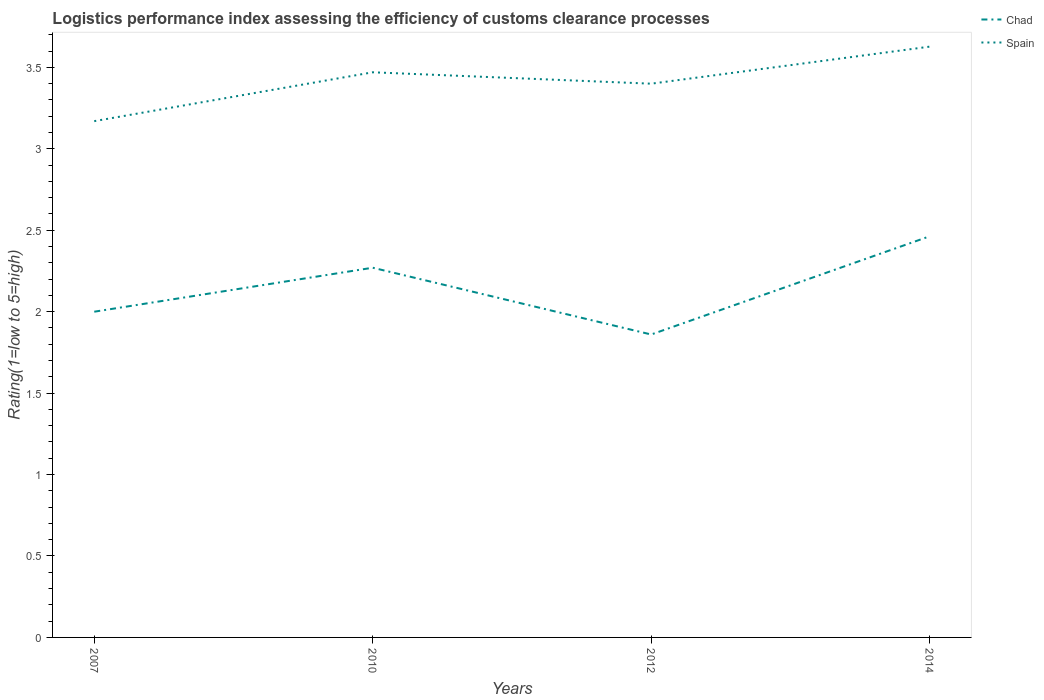How many different coloured lines are there?
Offer a terse response. 2. Does the line corresponding to Spain intersect with the line corresponding to Chad?
Offer a very short reply. No. Is the number of lines equal to the number of legend labels?
Your response must be concise. Yes. Across all years, what is the maximum Logistic performance index in Spain?
Make the answer very short. 3.17. What is the total Logistic performance index in Spain in the graph?
Keep it short and to the point. 0.07. What is the difference between the highest and the second highest Logistic performance index in Spain?
Make the answer very short. 0.46. How many lines are there?
Your response must be concise. 2. What is the difference between two consecutive major ticks on the Y-axis?
Provide a succinct answer. 0.5. Are the values on the major ticks of Y-axis written in scientific E-notation?
Keep it short and to the point. No. Does the graph contain any zero values?
Offer a very short reply. No. Where does the legend appear in the graph?
Provide a succinct answer. Top right. How many legend labels are there?
Offer a very short reply. 2. How are the legend labels stacked?
Offer a terse response. Vertical. What is the title of the graph?
Make the answer very short. Logistics performance index assessing the efficiency of customs clearance processes. What is the label or title of the X-axis?
Your answer should be very brief. Years. What is the label or title of the Y-axis?
Your answer should be very brief. Rating(1=low to 5=high). What is the Rating(1=low to 5=high) in Chad in 2007?
Provide a succinct answer. 2. What is the Rating(1=low to 5=high) in Spain in 2007?
Your answer should be very brief. 3.17. What is the Rating(1=low to 5=high) of Chad in 2010?
Your response must be concise. 2.27. What is the Rating(1=low to 5=high) in Spain in 2010?
Provide a short and direct response. 3.47. What is the Rating(1=low to 5=high) in Chad in 2012?
Provide a succinct answer. 1.86. What is the Rating(1=low to 5=high) in Chad in 2014?
Your response must be concise. 2.46. What is the Rating(1=low to 5=high) of Spain in 2014?
Your answer should be very brief. 3.63. Across all years, what is the maximum Rating(1=low to 5=high) of Chad?
Offer a terse response. 2.46. Across all years, what is the maximum Rating(1=low to 5=high) in Spain?
Your answer should be very brief. 3.63. Across all years, what is the minimum Rating(1=low to 5=high) in Chad?
Your response must be concise. 1.86. Across all years, what is the minimum Rating(1=low to 5=high) of Spain?
Give a very brief answer. 3.17. What is the total Rating(1=low to 5=high) in Chad in the graph?
Make the answer very short. 8.59. What is the total Rating(1=low to 5=high) in Spain in the graph?
Make the answer very short. 13.67. What is the difference between the Rating(1=low to 5=high) in Chad in 2007 and that in 2010?
Offer a terse response. -0.27. What is the difference between the Rating(1=low to 5=high) in Chad in 2007 and that in 2012?
Give a very brief answer. 0.14. What is the difference between the Rating(1=low to 5=high) of Spain in 2007 and that in 2012?
Your answer should be compact. -0.23. What is the difference between the Rating(1=low to 5=high) of Chad in 2007 and that in 2014?
Your answer should be very brief. -0.46. What is the difference between the Rating(1=low to 5=high) of Spain in 2007 and that in 2014?
Offer a very short reply. -0.46. What is the difference between the Rating(1=low to 5=high) in Chad in 2010 and that in 2012?
Offer a very short reply. 0.41. What is the difference between the Rating(1=low to 5=high) of Spain in 2010 and that in 2012?
Keep it short and to the point. 0.07. What is the difference between the Rating(1=low to 5=high) in Chad in 2010 and that in 2014?
Your response must be concise. -0.19. What is the difference between the Rating(1=low to 5=high) of Spain in 2010 and that in 2014?
Provide a succinct answer. -0.16. What is the difference between the Rating(1=low to 5=high) in Chad in 2012 and that in 2014?
Offer a very short reply. -0.6. What is the difference between the Rating(1=low to 5=high) in Spain in 2012 and that in 2014?
Provide a succinct answer. -0.23. What is the difference between the Rating(1=low to 5=high) in Chad in 2007 and the Rating(1=low to 5=high) in Spain in 2010?
Provide a short and direct response. -1.47. What is the difference between the Rating(1=low to 5=high) of Chad in 2007 and the Rating(1=low to 5=high) of Spain in 2012?
Make the answer very short. -1.4. What is the difference between the Rating(1=low to 5=high) of Chad in 2007 and the Rating(1=low to 5=high) of Spain in 2014?
Offer a very short reply. -1.63. What is the difference between the Rating(1=low to 5=high) in Chad in 2010 and the Rating(1=low to 5=high) in Spain in 2012?
Keep it short and to the point. -1.13. What is the difference between the Rating(1=low to 5=high) in Chad in 2010 and the Rating(1=low to 5=high) in Spain in 2014?
Your answer should be compact. -1.36. What is the difference between the Rating(1=low to 5=high) of Chad in 2012 and the Rating(1=low to 5=high) of Spain in 2014?
Offer a very short reply. -1.77. What is the average Rating(1=low to 5=high) in Chad per year?
Offer a terse response. 2.15. What is the average Rating(1=low to 5=high) in Spain per year?
Your answer should be very brief. 3.42. In the year 2007, what is the difference between the Rating(1=low to 5=high) of Chad and Rating(1=low to 5=high) of Spain?
Provide a succinct answer. -1.17. In the year 2012, what is the difference between the Rating(1=low to 5=high) of Chad and Rating(1=low to 5=high) of Spain?
Make the answer very short. -1.54. In the year 2014, what is the difference between the Rating(1=low to 5=high) of Chad and Rating(1=low to 5=high) of Spain?
Offer a very short reply. -1.16. What is the ratio of the Rating(1=low to 5=high) in Chad in 2007 to that in 2010?
Offer a very short reply. 0.88. What is the ratio of the Rating(1=low to 5=high) in Spain in 2007 to that in 2010?
Give a very brief answer. 0.91. What is the ratio of the Rating(1=low to 5=high) in Chad in 2007 to that in 2012?
Your response must be concise. 1.08. What is the ratio of the Rating(1=low to 5=high) in Spain in 2007 to that in 2012?
Your answer should be very brief. 0.93. What is the ratio of the Rating(1=low to 5=high) of Chad in 2007 to that in 2014?
Your answer should be very brief. 0.81. What is the ratio of the Rating(1=low to 5=high) in Spain in 2007 to that in 2014?
Ensure brevity in your answer.  0.87. What is the ratio of the Rating(1=low to 5=high) of Chad in 2010 to that in 2012?
Keep it short and to the point. 1.22. What is the ratio of the Rating(1=low to 5=high) in Spain in 2010 to that in 2012?
Give a very brief answer. 1.02. What is the ratio of the Rating(1=low to 5=high) of Chad in 2010 to that in 2014?
Your response must be concise. 0.92. What is the ratio of the Rating(1=low to 5=high) of Spain in 2010 to that in 2014?
Provide a succinct answer. 0.96. What is the ratio of the Rating(1=low to 5=high) in Chad in 2012 to that in 2014?
Give a very brief answer. 0.76. What is the ratio of the Rating(1=low to 5=high) in Spain in 2012 to that in 2014?
Your answer should be compact. 0.94. What is the difference between the highest and the second highest Rating(1=low to 5=high) in Chad?
Give a very brief answer. 0.19. What is the difference between the highest and the second highest Rating(1=low to 5=high) of Spain?
Provide a short and direct response. 0.16. What is the difference between the highest and the lowest Rating(1=low to 5=high) in Chad?
Provide a short and direct response. 0.6. What is the difference between the highest and the lowest Rating(1=low to 5=high) of Spain?
Provide a short and direct response. 0.46. 